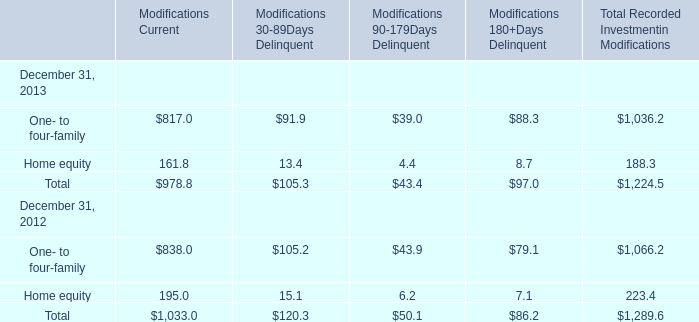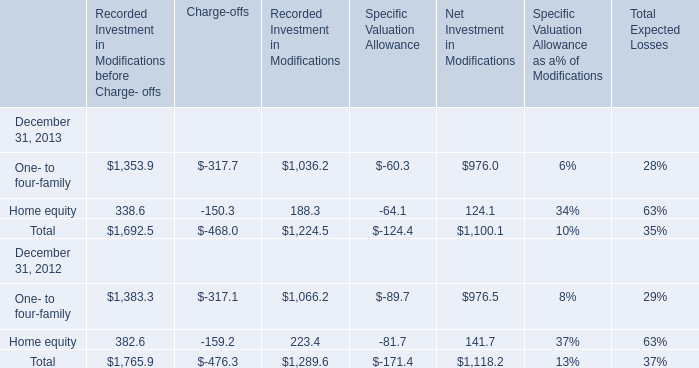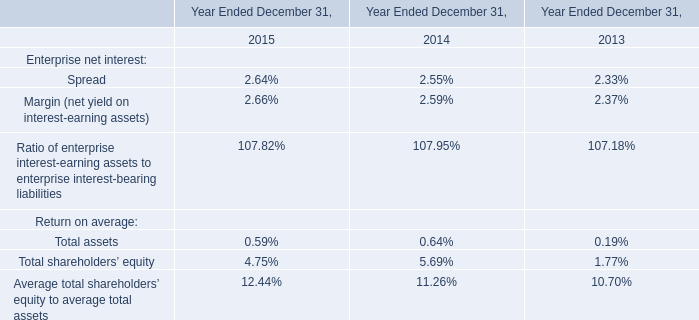What will Modifications Current be like in 2014 if it develops with the same increasing rate as current? 
Computations: (978.8 + ((978.8 * (978.8 - 1033.0)) / 1033.0))
Answer: 927.44379. 